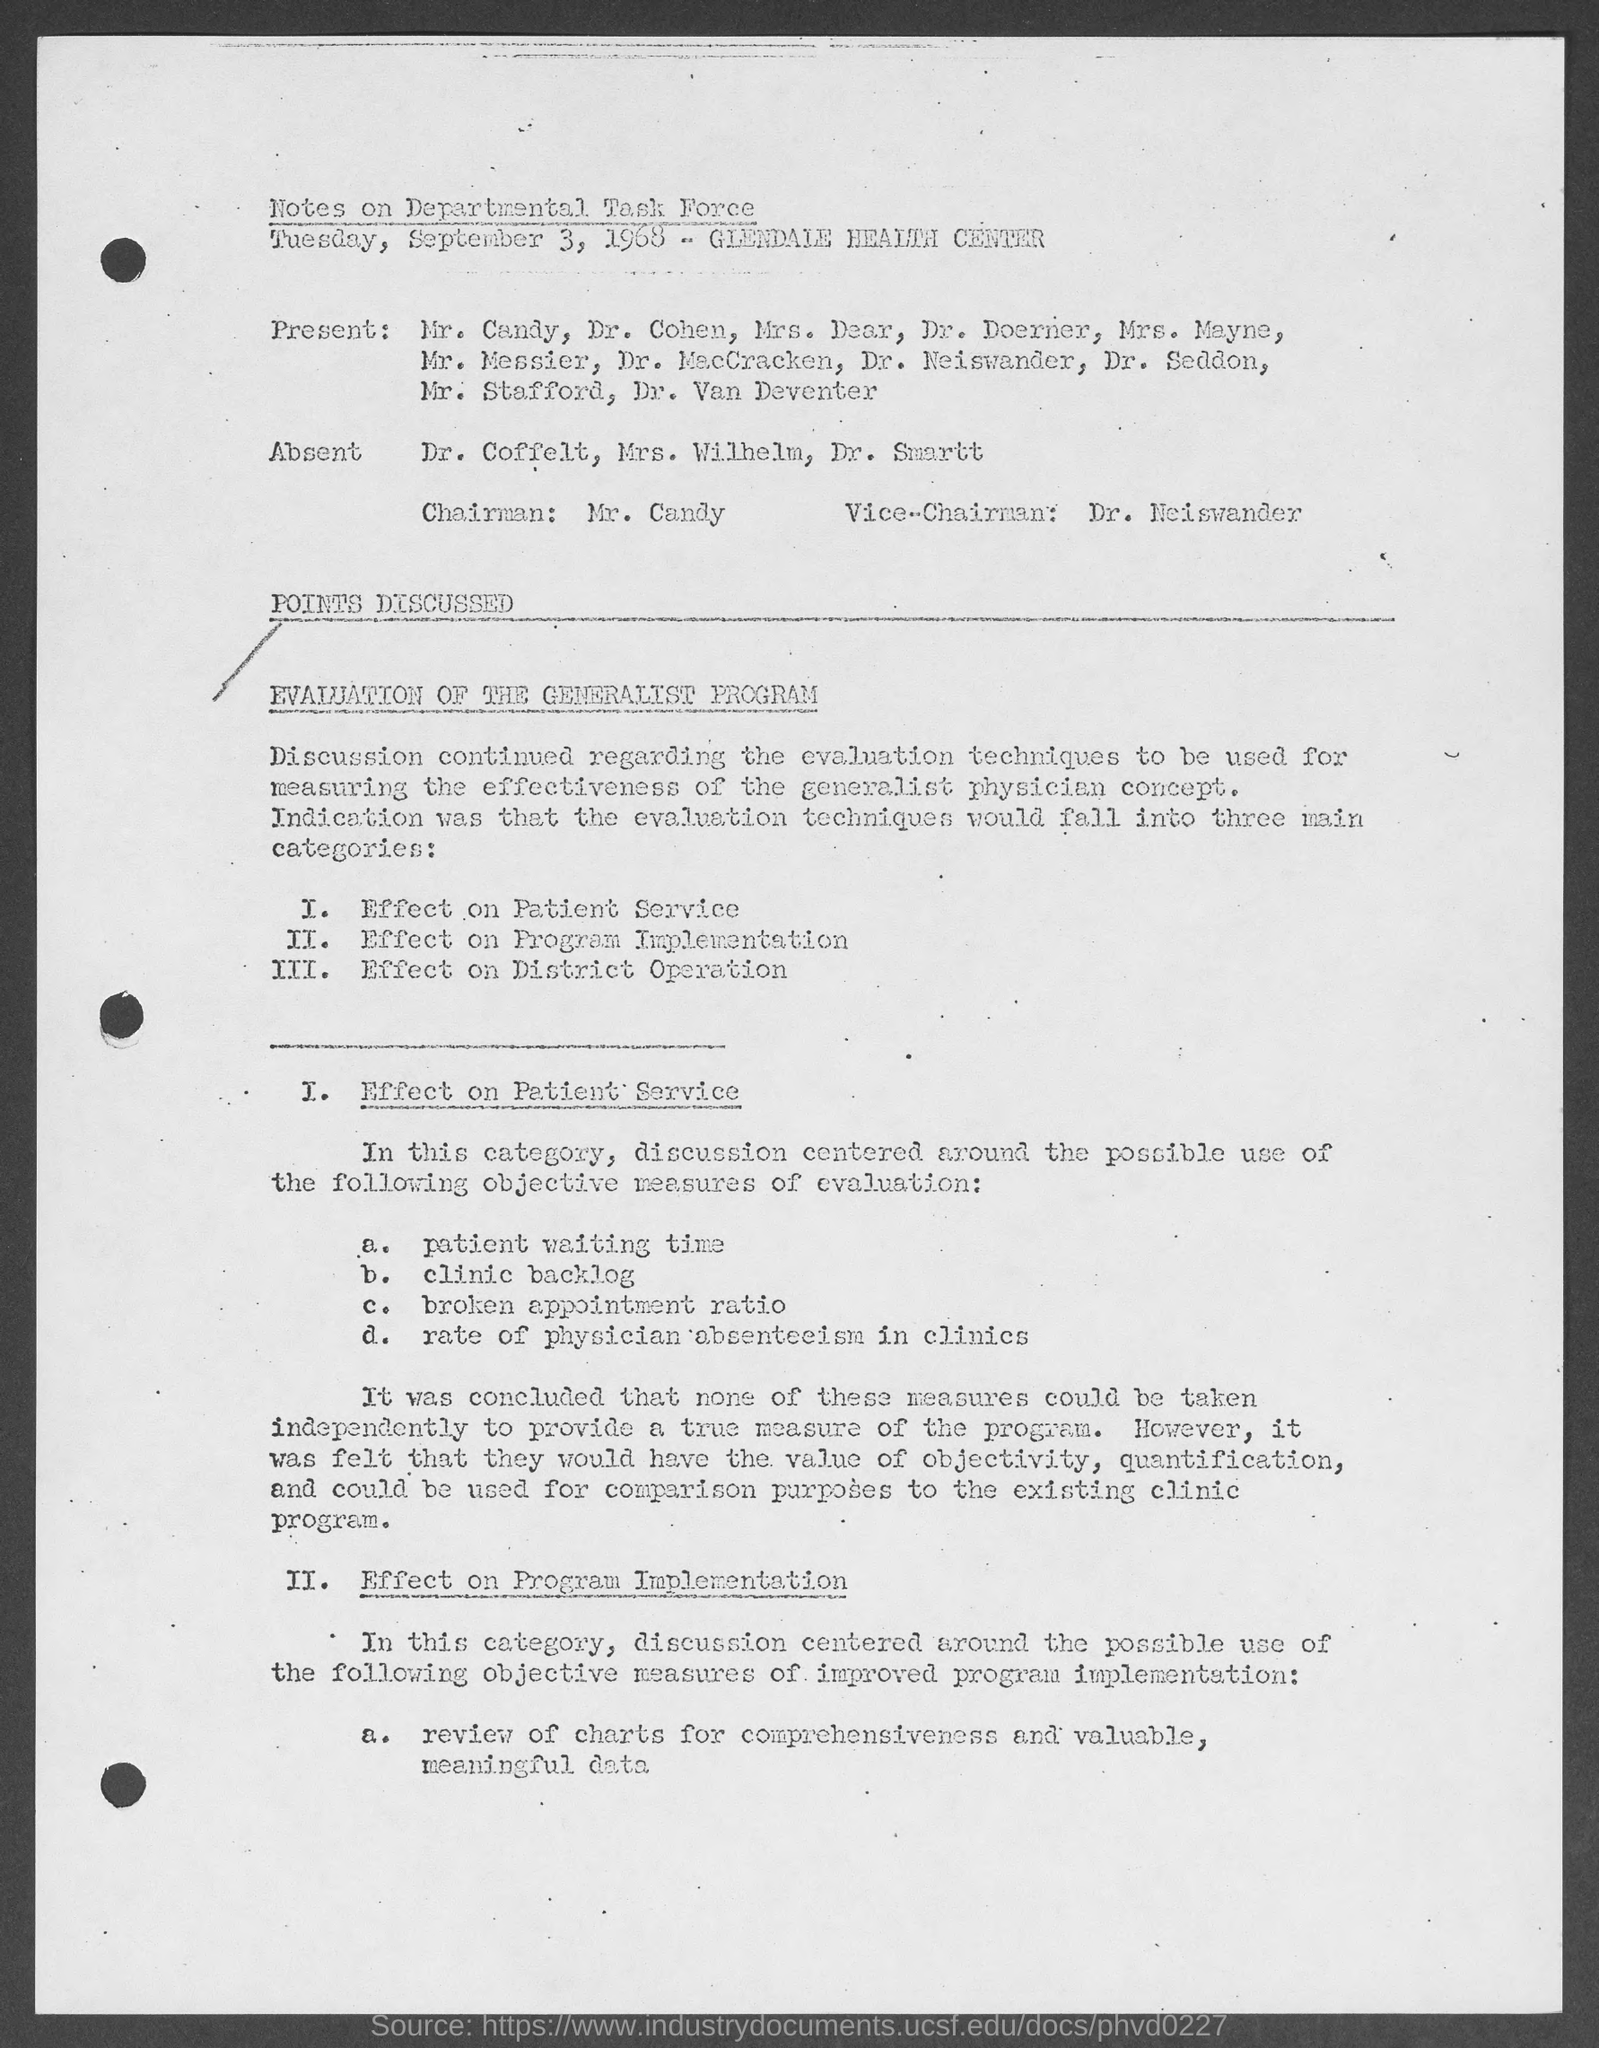What are the implications of the findings for the Generalist Program? The implications of the findings suggest that while the Generalist Program was under evaluation, the existing metrics might not fully capture its true value and effectiveness. It underscores a need for more nuanced evaluation criteria that can accurately reflect the program’s impact on patient service, program implementation, and district operation. 